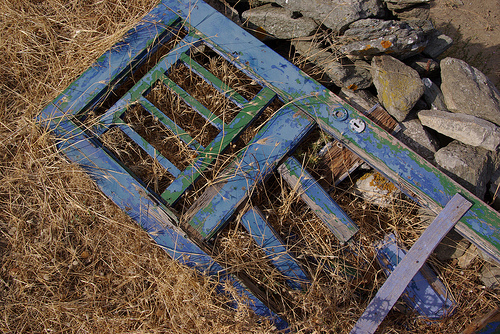<image>
Can you confirm if the door is under the straw? No. The door is not positioned under the straw. The vertical relationship between these objects is different. 